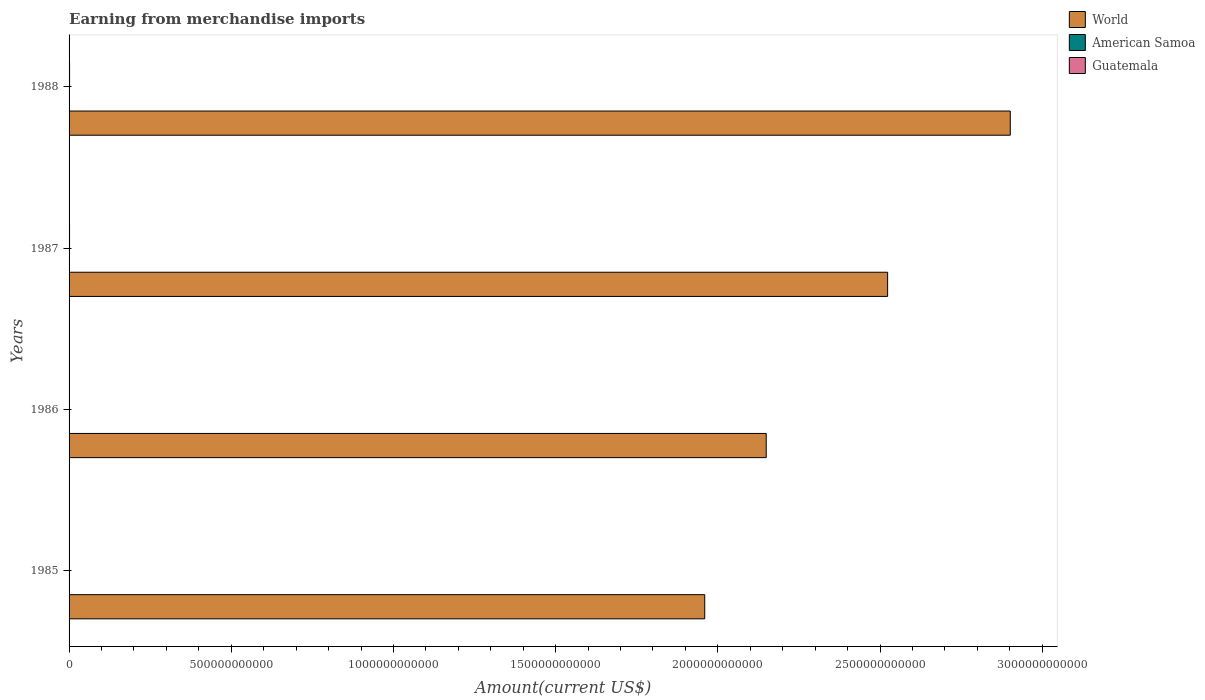How many bars are there on the 2nd tick from the top?
Ensure brevity in your answer.  3. What is the amount earned from merchandise imports in American Samoa in 1985?
Ensure brevity in your answer.  2.96e+08. Across all years, what is the maximum amount earned from merchandise imports in American Samoa?
Offer a terse response. 3.46e+08. Across all years, what is the minimum amount earned from merchandise imports in American Samoa?
Your answer should be very brief. 2.96e+08. What is the total amount earned from merchandise imports in World in the graph?
Your answer should be very brief. 9.53e+12. What is the difference between the amount earned from merchandise imports in Guatemala in 1986 and that in 1987?
Your response must be concise. -4.88e+08. What is the difference between the amount earned from merchandise imports in Guatemala in 1987 and the amount earned from merchandise imports in World in 1988?
Give a very brief answer. -2.90e+12. What is the average amount earned from merchandise imports in American Samoa per year?
Make the answer very short. 3.24e+08. In the year 1985, what is the difference between the amount earned from merchandise imports in American Samoa and amount earned from merchandise imports in World?
Ensure brevity in your answer.  -1.96e+12. What is the ratio of the amount earned from merchandise imports in American Samoa in 1987 to that in 1988?
Give a very brief answer. 1.02. Is the difference between the amount earned from merchandise imports in American Samoa in 1987 and 1988 greater than the difference between the amount earned from merchandise imports in World in 1987 and 1988?
Offer a very short reply. Yes. What is the difference between the highest and the second highest amount earned from merchandise imports in American Samoa?
Give a very brief answer. 7.00e+06. What is the difference between the highest and the lowest amount earned from merchandise imports in World?
Ensure brevity in your answer.  9.42e+11. In how many years, is the amount earned from merchandise imports in World greater than the average amount earned from merchandise imports in World taken over all years?
Give a very brief answer. 2. What does the 3rd bar from the top in 1985 represents?
Provide a short and direct response. World. What does the 1st bar from the bottom in 1985 represents?
Your answer should be very brief. World. Is it the case that in every year, the sum of the amount earned from merchandise imports in American Samoa and amount earned from merchandise imports in World is greater than the amount earned from merchandise imports in Guatemala?
Make the answer very short. Yes. How many bars are there?
Your answer should be compact. 12. How many years are there in the graph?
Offer a terse response. 4. What is the difference between two consecutive major ticks on the X-axis?
Your answer should be compact. 5.00e+11. Does the graph contain any zero values?
Your answer should be very brief. No. Does the graph contain grids?
Offer a very short reply. No. What is the title of the graph?
Give a very brief answer. Earning from merchandise imports. What is the label or title of the X-axis?
Ensure brevity in your answer.  Amount(current US$). What is the label or title of the Y-axis?
Your answer should be compact. Years. What is the Amount(current US$) in World in 1985?
Give a very brief answer. 1.96e+12. What is the Amount(current US$) in American Samoa in 1985?
Offer a very short reply. 2.96e+08. What is the Amount(current US$) of Guatemala in 1985?
Ensure brevity in your answer.  1.18e+09. What is the Amount(current US$) of World in 1986?
Keep it short and to the point. 2.15e+12. What is the Amount(current US$) in American Samoa in 1986?
Ensure brevity in your answer.  3.13e+08. What is the Amount(current US$) of Guatemala in 1986?
Make the answer very short. 9.59e+08. What is the Amount(current US$) in World in 1987?
Your answer should be compact. 2.52e+12. What is the Amount(current US$) in American Samoa in 1987?
Give a very brief answer. 3.46e+08. What is the Amount(current US$) of Guatemala in 1987?
Provide a short and direct response. 1.45e+09. What is the Amount(current US$) in World in 1988?
Provide a short and direct response. 2.90e+12. What is the Amount(current US$) in American Samoa in 1988?
Provide a short and direct response. 3.39e+08. What is the Amount(current US$) of Guatemala in 1988?
Keep it short and to the point. 1.56e+09. Across all years, what is the maximum Amount(current US$) in World?
Provide a short and direct response. 2.90e+12. Across all years, what is the maximum Amount(current US$) of American Samoa?
Offer a terse response. 3.46e+08. Across all years, what is the maximum Amount(current US$) in Guatemala?
Offer a terse response. 1.56e+09. Across all years, what is the minimum Amount(current US$) of World?
Offer a very short reply. 1.96e+12. Across all years, what is the minimum Amount(current US$) of American Samoa?
Provide a succinct answer. 2.96e+08. Across all years, what is the minimum Amount(current US$) in Guatemala?
Provide a succinct answer. 9.59e+08. What is the total Amount(current US$) in World in the graph?
Provide a succinct answer. 9.53e+12. What is the total Amount(current US$) of American Samoa in the graph?
Offer a very short reply. 1.29e+09. What is the total Amount(current US$) in Guatemala in the graph?
Offer a terse response. 5.14e+09. What is the difference between the Amount(current US$) of World in 1985 and that in 1986?
Your answer should be very brief. -1.90e+11. What is the difference between the Amount(current US$) of American Samoa in 1985 and that in 1986?
Your response must be concise. -1.70e+07. What is the difference between the Amount(current US$) of Guatemala in 1985 and that in 1986?
Keep it short and to the point. 2.16e+08. What is the difference between the Amount(current US$) in World in 1985 and that in 1987?
Offer a terse response. -5.64e+11. What is the difference between the Amount(current US$) of American Samoa in 1985 and that in 1987?
Give a very brief answer. -5.00e+07. What is the difference between the Amount(current US$) of Guatemala in 1985 and that in 1987?
Your response must be concise. -2.72e+08. What is the difference between the Amount(current US$) of World in 1985 and that in 1988?
Keep it short and to the point. -9.42e+11. What is the difference between the Amount(current US$) in American Samoa in 1985 and that in 1988?
Make the answer very short. -4.30e+07. What is the difference between the Amount(current US$) of Guatemala in 1985 and that in 1988?
Your answer should be compact. -3.82e+08. What is the difference between the Amount(current US$) in World in 1986 and that in 1987?
Your answer should be compact. -3.74e+11. What is the difference between the Amount(current US$) of American Samoa in 1986 and that in 1987?
Your answer should be very brief. -3.30e+07. What is the difference between the Amount(current US$) in Guatemala in 1986 and that in 1987?
Provide a short and direct response. -4.88e+08. What is the difference between the Amount(current US$) of World in 1986 and that in 1988?
Provide a succinct answer. -7.52e+11. What is the difference between the Amount(current US$) of American Samoa in 1986 and that in 1988?
Keep it short and to the point. -2.60e+07. What is the difference between the Amount(current US$) of Guatemala in 1986 and that in 1988?
Provide a succinct answer. -5.98e+08. What is the difference between the Amount(current US$) of World in 1987 and that in 1988?
Provide a succinct answer. -3.78e+11. What is the difference between the Amount(current US$) of Guatemala in 1987 and that in 1988?
Your response must be concise. -1.10e+08. What is the difference between the Amount(current US$) of World in 1985 and the Amount(current US$) of American Samoa in 1986?
Provide a short and direct response. 1.96e+12. What is the difference between the Amount(current US$) in World in 1985 and the Amount(current US$) in Guatemala in 1986?
Make the answer very short. 1.96e+12. What is the difference between the Amount(current US$) of American Samoa in 1985 and the Amount(current US$) of Guatemala in 1986?
Provide a succinct answer. -6.63e+08. What is the difference between the Amount(current US$) in World in 1985 and the Amount(current US$) in American Samoa in 1987?
Make the answer very short. 1.96e+12. What is the difference between the Amount(current US$) of World in 1985 and the Amount(current US$) of Guatemala in 1987?
Your answer should be very brief. 1.96e+12. What is the difference between the Amount(current US$) in American Samoa in 1985 and the Amount(current US$) in Guatemala in 1987?
Provide a short and direct response. -1.15e+09. What is the difference between the Amount(current US$) of World in 1985 and the Amount(current US$) of American Samoa in 1988?
Provide a short and direct response. 1.96e+12. What is the difference between the Amount(current US$) of World in 1985 and the Amount(current US$) of Guatemala in 1988?
Your answer should be very brief. 1.96e+12. What is the difference between the Amount(current US$) of American Samoa in 1985 and the Amount(current US$) of Guatemala in 1988?
Keep it short and to the point. -1.26e+09. What is the difference between the Amount(current US$) in World in 1986 and the Amount(current US$) in American Samoa in 1987?
Offer a terse response. 2.15e+12. What is the difference between the Amount(current US$) in World in 1986 and the Amount(current US$) in Guatemala in 1987?
Your answer should be very brief. 2.15e+12. What is the difference between the Amount(current US$) of American Samoa in 1986 and the Amount(current US$) of Guatemala in 1987?
Offer a terse response. -1.13e+09. What is the difference between the Amount(current US$) of World in 1986 and the Amount(current US$) of American Samoa in 1988?
Make the answer very short. 2.15e+12. What is the difference between the Amount(current US$) in World in 1986 and the Amount(current US$) in Guatemala in 1988?
Your answer should be very brief. 2.15e+12. What is the difference between the Amount(current US$) in American Samoa in 1986 and the Amount(current US$) in Guatemala in 1988?
Give a very brief answer. -1.24e+09. What is the difference between the Amount(current US$) in World in 1987 and the Amount(current US$) in American Samoa in 1988?
Keep it short and to the point. 2.52e+12. What is the difference between the Amount(current US$) of World in 1987 and the Amount(current US$) of Guatemala in 1988?
Your response must be concise. 2.52e+12. What is the difference between the Amount(current US$) in American Samoa in 1987 and the Amount(current US$) in Guatemala in 1988?
Your response must be concise. -1.21e+09. What is the average Amount(current US$) of World per year?
Ensure brevity in your answer.  2.38e+12. What is the average Amount(current US$) of American Samoa per year?
Your answer should be very brief. 3.24e+08. What is the average Amount(current US$) in Guatemala per year?
Ensure brevity in your answer.  1.28e+09. In the year 1985, what is the difference between the Amount(current US$) of World and Amount(current US$) of American Samoa?
Keep it short and to the point. 1.96e+12. In the year 1985, what is the difference between the Amount(current US$) of World and Amount(current US$) of Guatemala?
Offer a terse response. 1.96e+12. In the year 1985, what is the difference between the Amount(current US$) in American Samoa and Amount(current US$) in Guatemala?
Your answer should be compact. -8.79e+08. In the year 1986, what is the difference between the Amount(current US$) in World and Amount(current US$) in American Samoa?
Give a very brief answer. 2.15e+12. In the year 1986, what is the difference between the Amount(current US$) of World and Amount(current US$) of Guatemala?
Your response must be concise. 2.15e+12. In the year 1986, what is the difference between the Amount(current US$) of American Samoa and Amount(current US$) of Guatemala?
Make the answer very short. -6.46e+08. In the year 1987, what is the difference between the Amount(current US$) of World and Amount(current US$) of American Samoa?
Provide a succinct answer. 2.52e+12. In the year 1987, what is the difference between the Amount(current US$) in World and Amount(current US$) in Guatemala?
Offer a terse response. 2.52e+12. In the year 1987, what is the difference between the Amount(current US$) in American Samoa and Amount(current US$) in Guatemala?
Give a very brief answer. -1.10e+09. In the year 1988, what is the difference between the Amount(current US$) in World and Amount(current US$) in American Samoa?
Give a very brief answer. 2.90e+12. In the year 1988, what is the difference between the Amount(current US$) of World and Amount(current US$) of Guatemala?
Ensure brevity in your answer.  2.90e+12. In the year 1988, what is the difference between the Amount(current US$) in American Samoa and Amount(current US$) in Guatemala?
Keep it short and to the point. -1.22e+09. What is the ratio of the Amount(current US$) in World in 1985 to that in 1986?
Provide a short and direct response. 0.91. What is the ratio of the Amount(current US$) in American Samoa in 1985 to that in 1986?
Offer a terse response. 0.95. What is the ratio of the Amount(current US$) in Guatemala in 1985 to that in 1986?
Offer a terse response. 1.23. What is the ratio of the Amount(current US$) in World in 1985 to that in 1987?
Your response must be concise. 0.78. What is the ratio of the Amount(current US$) of American Samoa in 1985 to that in 1987?
Your response must be concise. 0.86. What is the ratio of the Amount(current US$) of Guatemala in 1985 to that in 1987?
Your answer should be very brief. 0.81. What is the ratio of the Amount(current US$) in World in 1985 to that in 1988?
Provide a succinct answer. 0.68. What is the ratio of the Amount(current US$) of American Samoa in 1985 to that in 1988?
Offer a terse response. 0.87. What is the ratio of the Amount(current US$) in Guatemala in 1985 to that in 1988?
Keep it short and to the point. 0.75. What is the ratio of the Amount(current US$) in World in 1986 to that in 1987?
Keep it short and to the point. 0.85. What is the ratio of the Amount(current US$) in American Samoa in 1986 to that in 1987?
Make the answer very short. 0.9. What is the ratio of the Amount(current US$) in Guatemala in 1986 to that in 1987?
Offer a very short reply. 0.66. What is the ratio of the Amount(current US$) in World in 1986 to that in 1988?
Keep it short and to the point. 0.74. What is the ratio of the Amount(current US$) of American Samoa in 1986 to that in 1988?
Give a very brief answer. 0.92. What is the ratio of the Amount(current US$) of Guatemala in 1986 to that in 1988?
Give a very brief answer. 0.62. What is the ratio of the Amount(current US$) in World in 1987 to that in 1988?
Offer a very short reply. 0.87. What is the ratio of the Amount(current US$) in American Samoa in 1987 to that in 1988?
Provide a short and direct response. 1.02. What is the ratio of the Amount(current US$) in Guatemala in 1987 to that in 1988?
Your answer should be very brief. 0.93. What is the difference between the highest and the second highest Amount(current US$) in World?
Provide a short and direct response. 3.78e+11. What is the difference between the highest and the second highest Amount(current US$) of Guatemala?
Make the answer very short. 1.10e+08. What is the difference between the highest and the lowest Amount(current US$) in World?
Keep it short and to the point. 9.42e+11. What is the difference between the highest and the lowest Amount(current US$) in Guatemala?
Ensure brevity in your answer.  5.98e+08. 